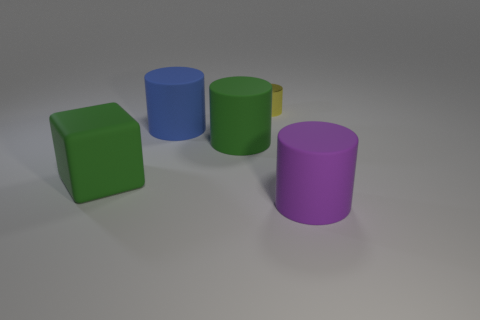Are there any other things that have the same size as the yellow cylinder?
Give a very brief answer. No. Are there any other things that are the same color as the shiny cylinder?
Keep it short and to the point. No. How many cyan spheres have the same material as the cube?
Provide a short and direct response. 0. What is the shape of the large object that is the same color as the block?
Give a very brief answer. Cylinder. Do the object that is right of the tiny yellow shiny object and the blue thing have the same shape?
Offer a terse response. Yes. What is the color of the block that is the same material as the big purple thing?
Offer a very short reply. Green. There is a green object that is behind the green rubber thing to the left of the big blue rubber cylinder; is there a blue thing right of it?
Offer a terse response. No. Is the number of small yellow objects that are right of the purple matte cylinder less than the number of large yellow metal spheres?
Make the answer very short. No. Are there any purple things that have the same shape as the blue matte object?
Your answer should be very brief. Yes. What shape is the green object that is the same size as the green cylinder?
Make the answer very short. Cube. 